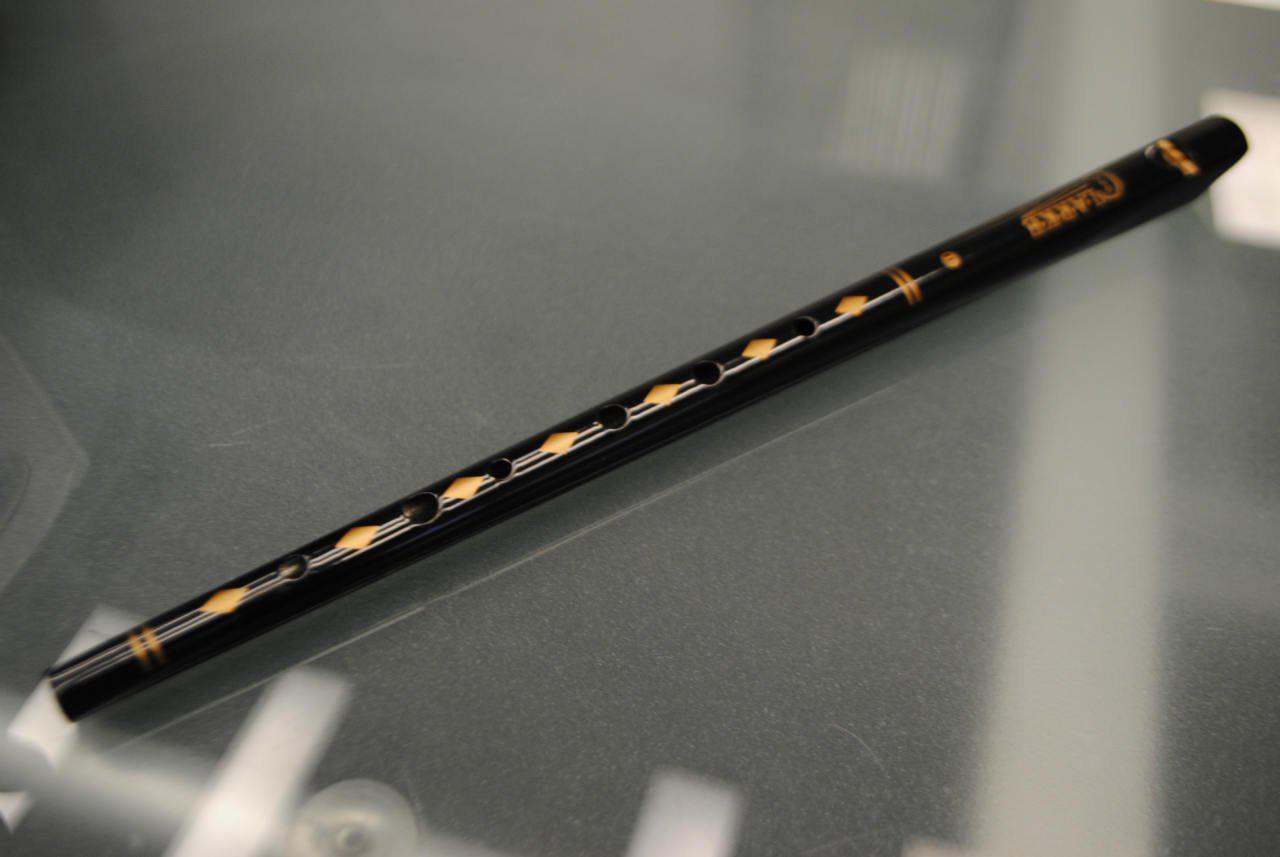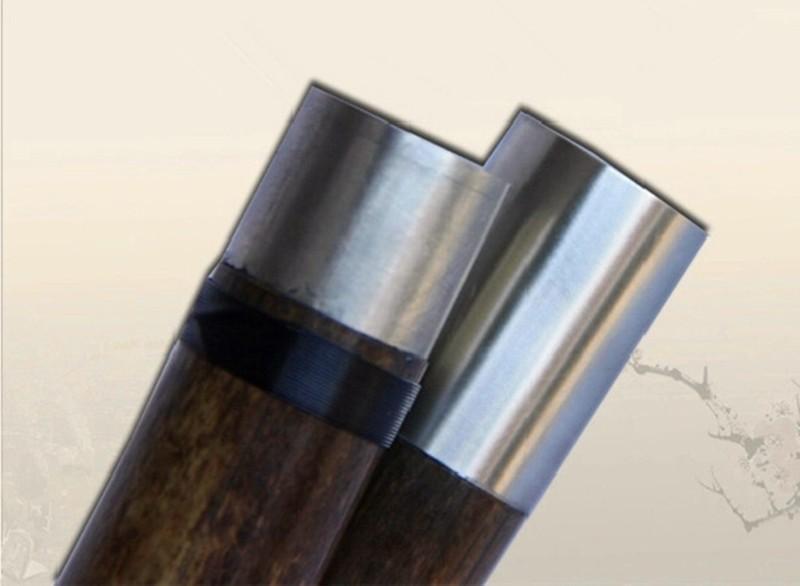The first image is the image on the left, the second image is the image on the right. Examine the images to the left and right. Is the description "There is a single flute in the left image." accurate? Answer yes or no. Yes. The first image is the image on the left, the second image is the image on the right. Evaluate the accuracy of this statement regarding the images: "One image contains a single flute, and the other image shows two silver metal ends that overlap.". Is it true? Answer yes or no. Yes. 